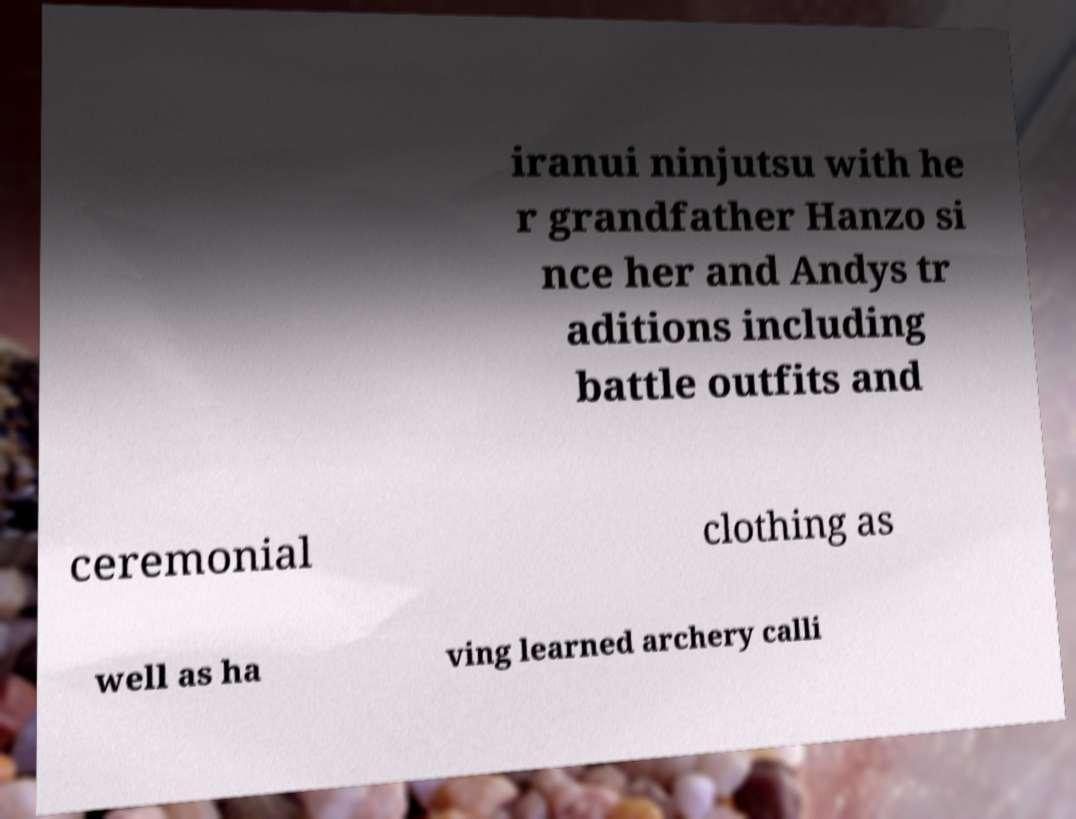Please identify and transcribe the text found in this image. iranui ninjutsu with he r grandfather Hanzo si nce her and Andys tr aditions including battle outfits and ceremonial clothing as well as ha ving learned archery calli 